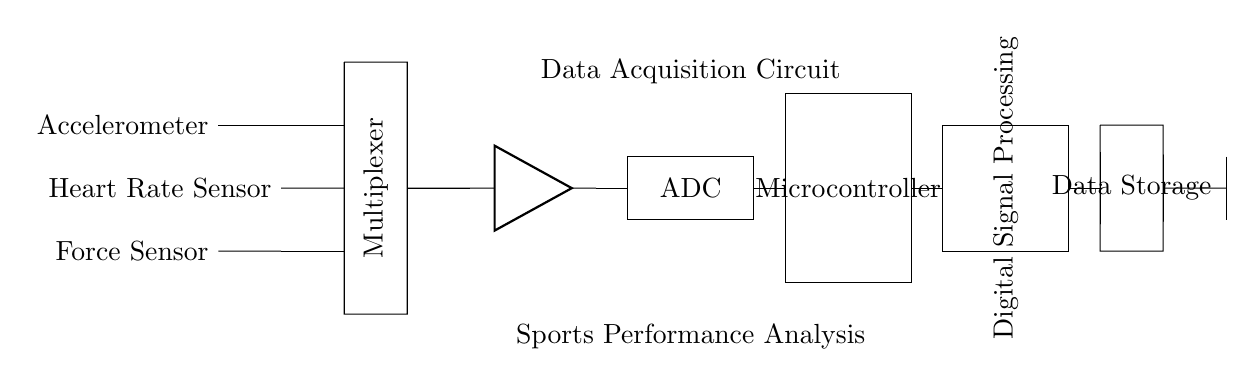What type of sensors are used in this circuit? The circuit includes an accelerometer, heart rate sensor, and force sensor, which are clearly labeled in the diagram.
Answer: accelerometer, heart rate sensor, force sensor What component combines the signals from the sensors? The multiplexer is named in the diagram and connects the outputs of the various sensors, allowing the selection of one signal to be read at a time.
Answer: multiplexer What function does the amplifier serve in this circuit? The amplifier boosts the signals coming from the sensors, as indicated by its position in the schematic after the multiplexer, improving the signal before it is digitized.
Answer: signal amplification Where does the data go after being processed by the microcontroller? The data storage unit follows the microcontroller in the diagram, which implies that processed data is stored there for further analysis or transmission.
Answer: data storage Which component is responsible for converting analog signals to digital? The ADC, which is explicitly noted in the schematic, is designed to convert the analog output from the sensors into digital signals that can be processed by the microcontroller.
Answer: ADC How does the circuit transmit data wirelessly? The circuit has an antenna drawn to represent the wireless transmission line, indicating that the processed data is sent to an external device wirelessly.
Answer: antenna Explain the role of digital signal processing in this circuit. Digital signal processing is shown as a separate unit after the microcontroller, indicating its function is to analyze the digitized data further, applying algorithms for performance analysis.
Answer: data analysis 